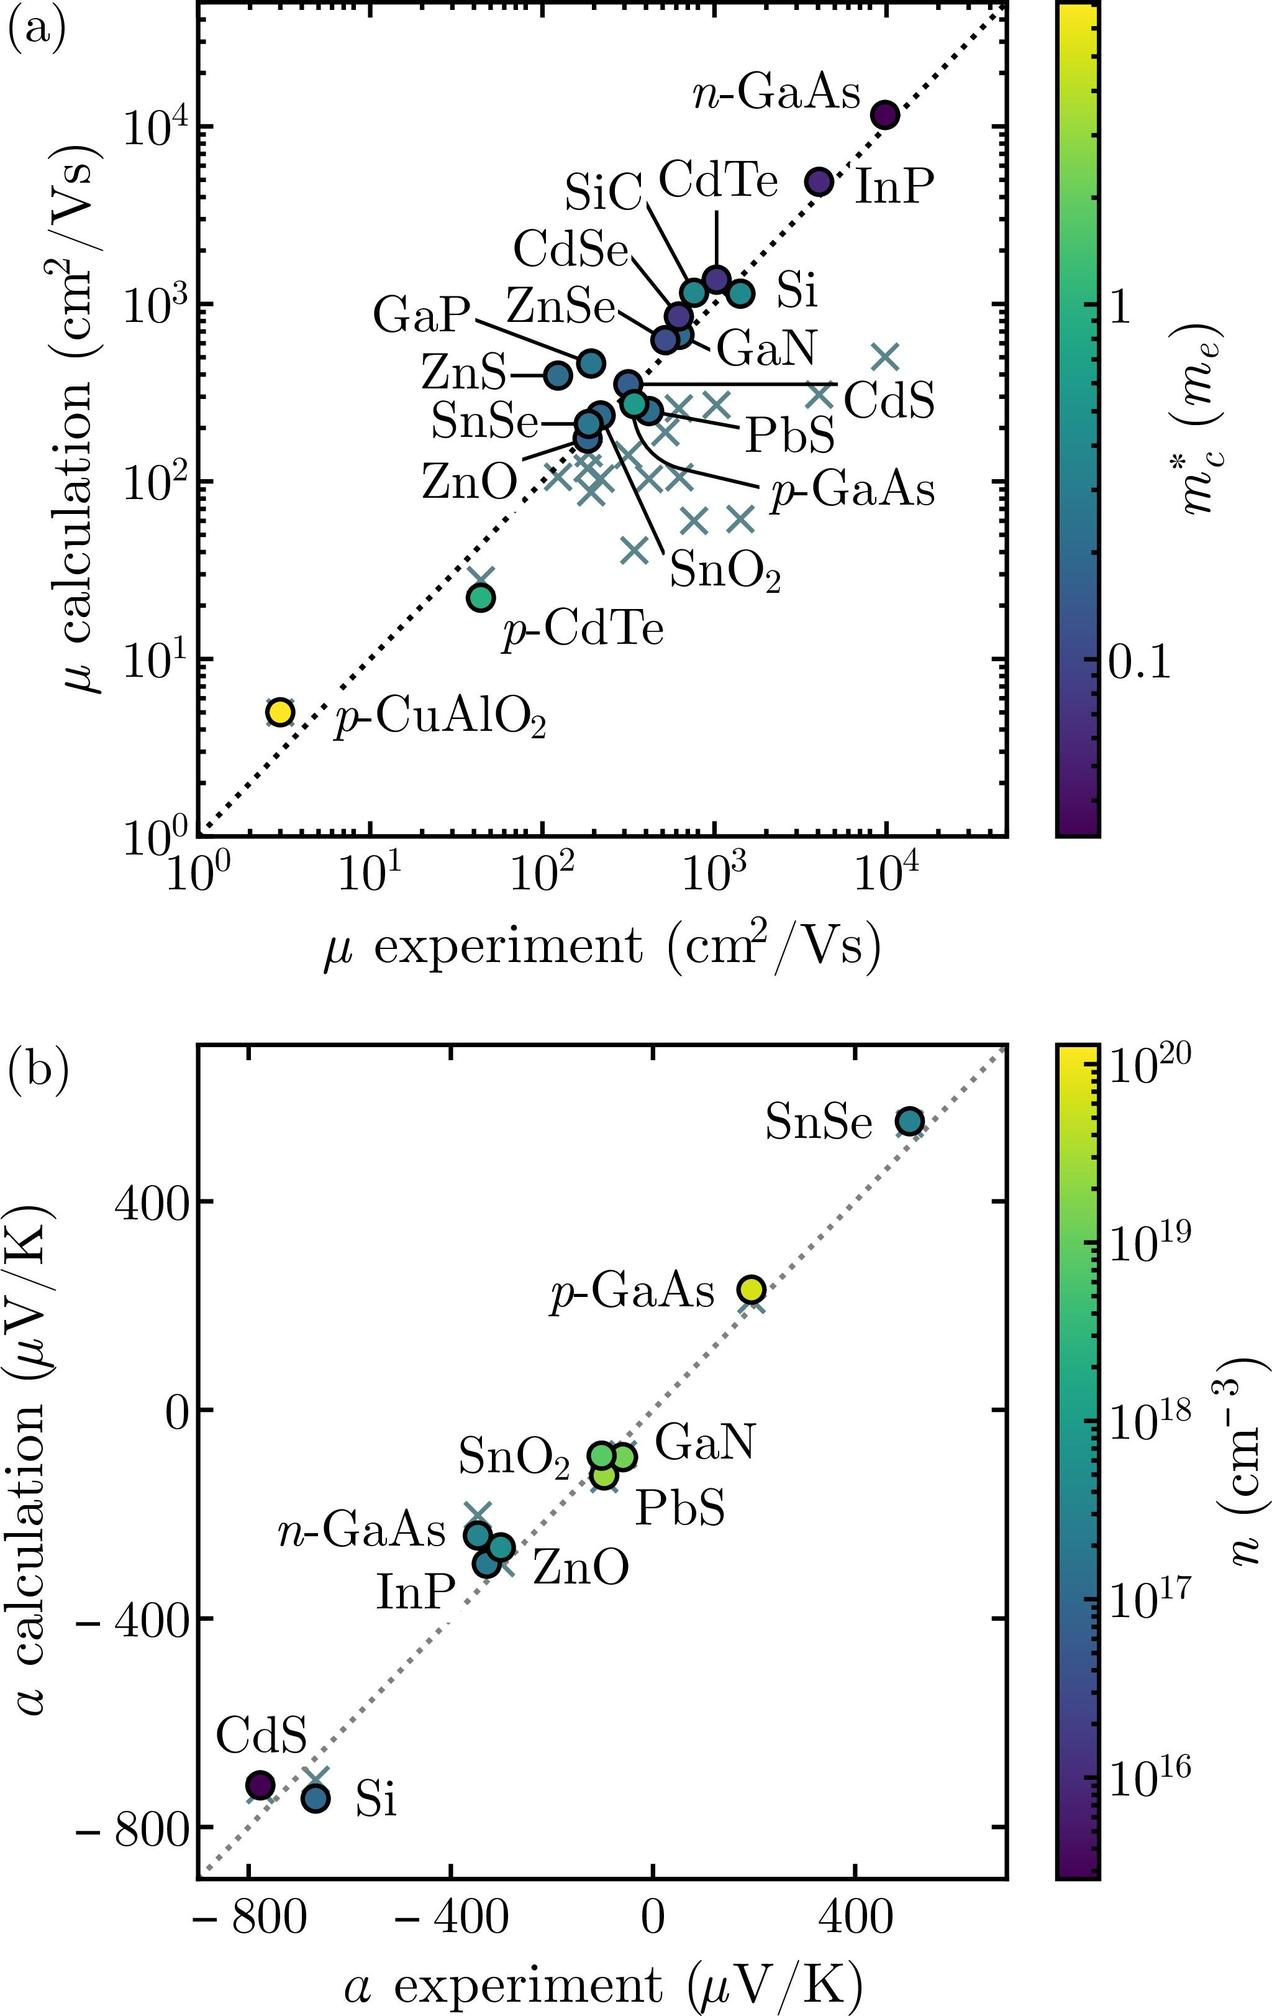According to Figure (b), what is the approximate Seebeck coefficient (α experiment) for CdS? A) \( -600 \ \mu V/K \) B) \( -200 \ \mu V/K \) C) \( 200 \ \mu V/K \) D) \( 600 \ \mu V/K \) In the provided plot (Figure b), we observe various materials plotted against their Seebeck coefficients. Specifically, the marker for CdS can be pinpointed at a value slightly above \( -600 \ \mu V/K \) on the horizontal axis, which represents the experimental Seebeck coefficient. Given the available options, the closest approximate value for the Seebeck coefficient of CdS is \( -600 \ \mu V/K \), making choice A) the correct answer. This plot not only provides specific values but also gives insight into the comparison of the experimental and theoretical Seebeck coefficients for a range of semiconducting materials, with the color gradient indicating carrier concentration (\( n \)) across the semiconductor spectrum. 